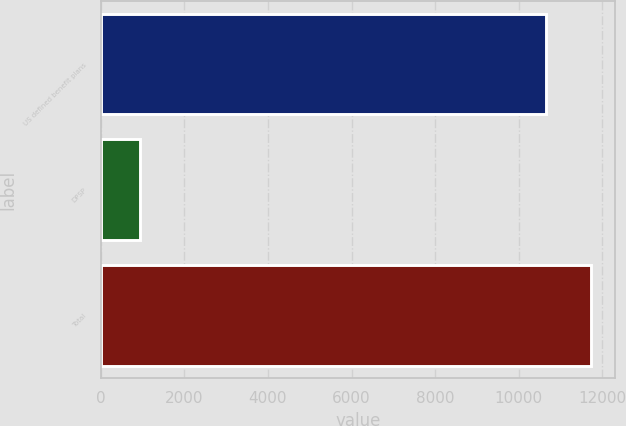Convert chart to OTSL. <chart><loc_0><loc_0><loc_500><loc_500><bar_chart><fcel>US defined benefit plans<fcel>DPSP<fcel>Total<nl><fcel>10662<fcel>945<fcel>11728.2<nl></chart> 